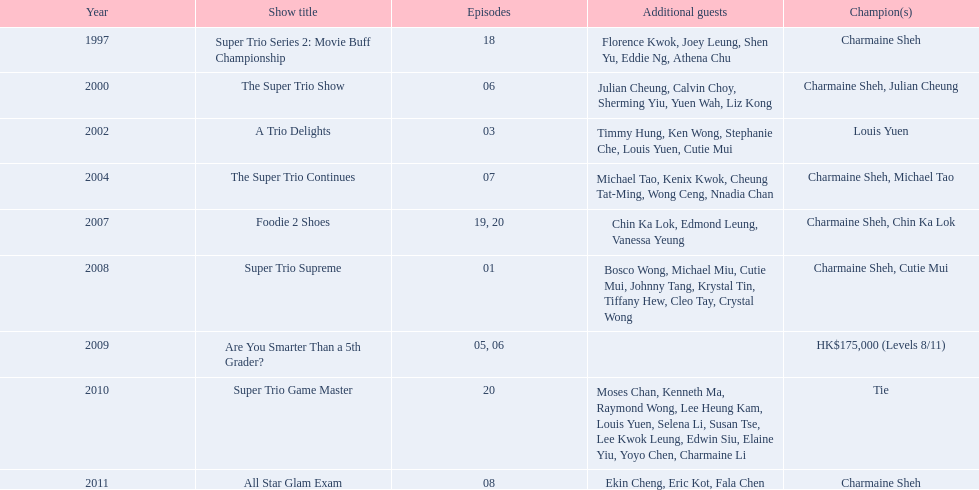Could you parse the entire table? {'header': ['Year', 'Show title', 'Episodes', 'Additional guests', 'Champion(s)'], 'rows': [['1997', 'Super Trio Series 2: Movie Buff Championship', '18', 'Florence Kwok, Joey Leung, Shen Yu, Eddie Ng, Athena Chu', 'Charmaine Sheh'], ['2000', 'The Super Trio Show', '06', 'Julian Cheung, Calvin Choy, Sherming Yiu, Yuen Wah, Liz Kong', 'Charmaine Sheh, Julian Cheung'], ['2002', 'A Trio Delights', '03', 'Timmy Hung, Ken Wong, Stephanie Che, Louis Yuen, Cutie Mui', 'Louis Yuen'], ['2004', 'The Super Trio Continues', '07', 'Michael Tao, Kenix Kwok, Cheung Tat-Ming, Wong Ceng, Nnadia Chan', 'Charmaine Sheh, Michael Tao'], ['2007', 'Foodie 2 Shoes', '19, 20', 'Chin Ka Lok, Edmond Leung, Vanessa Yeung', 'Charmaine Sheh, Chin Ka Lok'], ['2008', 'Super Trio Supreme', '01', 'Bosco Wong, Michael Miu, Cutie Mui, Johnny Tang, Krystal Tin, Tiffany Hew, Cleo Tay, Crystal Wong', 'Charmaine Sheh, Cutie Mui'], ['2009', 'Are You Smarter Than a 5th Grader?', '05, 06', '', 'HK$175,000 (Levels 8/11)'], ['2010', 'Super Trio Game Master', '20', 'Moses Chan, Kenneth Ma, Raymond Wong, Lee Heung Kam, Louis Yuen, Selena Li, Susan Tse, Lee Kwok Leung, Edwin Siu, Elaine Yiu, Yoyo Chen, Charmaine Li', 'Tie'], ['2011', 'All Star Glam Exam', '08', 'Ekin Cheng, Eric Kot, Fala Chen', 'Charmaine Sheh']]} How many of shows had at least 5 episodes? 7. 